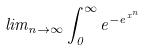Convert formula to latex. <formula><loc_0><loc_0><loc_500><loc_500>l i m _ { n \rightarrow \infty } \int _ { 0 } ^ { \infty } e ^ { - e ^ { x ^ { n } } }</formula> 